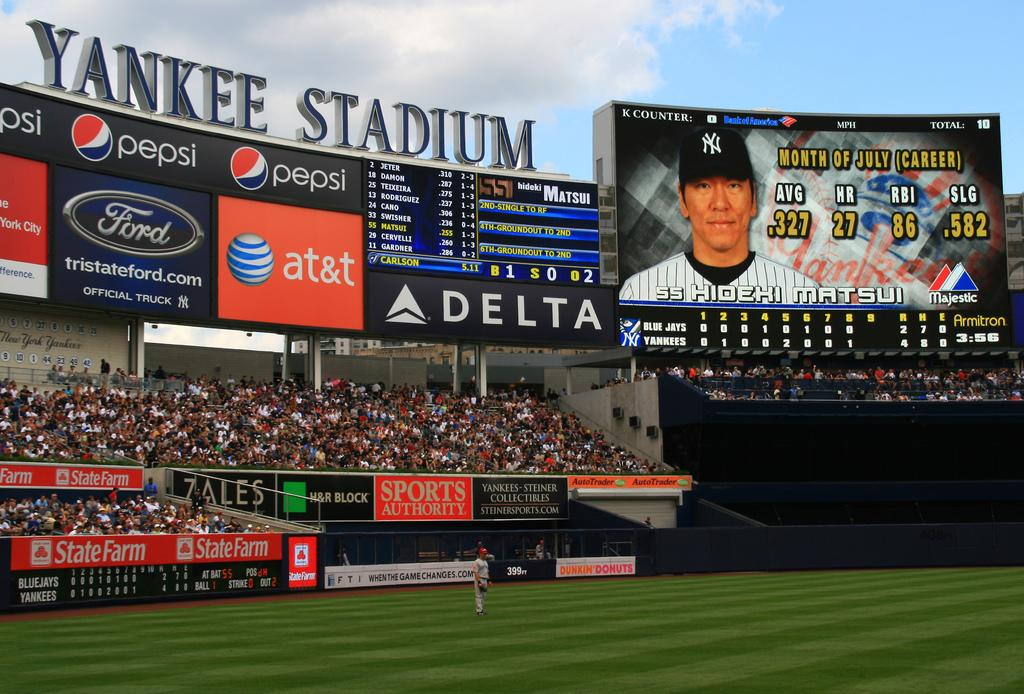Provide a one-sentence caption for the provided image. Hidehi Matsui is up to bat during the Yankees game in New York City. 